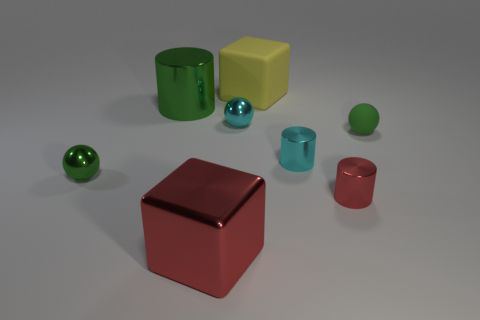Subtract all cyan cubes. How many green balls are left? 2 Subtract all small cylinders. How many cylinders are left? 1 Subtract 1 cylinders. How many cylinders are left? 2 Add 1 big red blocks. How many objects exist? 9 Subtract all large yellow rubber blocks. Subtract all rubber balls. How many objects are left? 6 Add 4 balls. How many balls are left? 7 Add 4 green things. How many green things exist? 7 Subtract 1 cyan spheres. How many objects are left? 7 Subtract all balls. How many objects are left? 5 